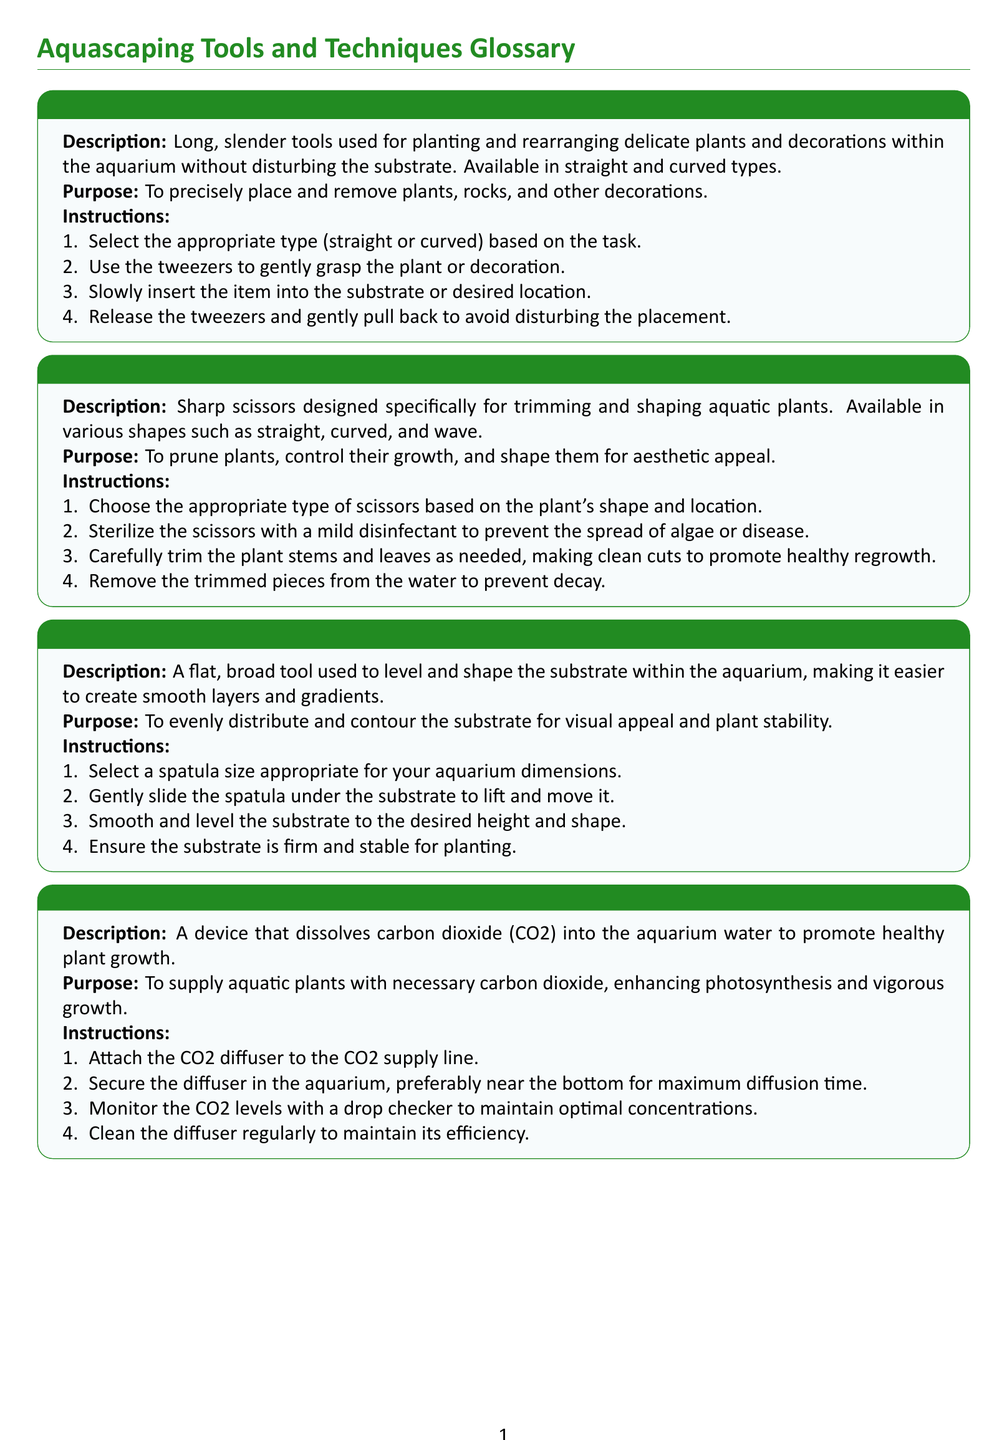What is the purpose of aquarium tweezers? The purpose of aquarium tweezers is to precisely place and remove plants, rocks, and other decorations.
Answer: To precisely place and remove plants, rocks, and other decorations What should you do before using aquarium scissors? Before using aquarium scissors, you should sterilize them with a mild disinfectant to prevent the spread of algae or disease.
Answer: Sterilize the scissors What is aquarium rockwool used for? Aquarium rockwool is used to provide initial support for plant roots and ensure they establish properly in the substrate.
Answer: To provide initial support for plant roots What type of tool is an aquarium substrate spatula? An aquarium substrate spatula is a flat, broad tool used to level and shape the substrate.
Answer: A flat, broad tool How many types of aquarium scissors are available? There are various shapes of aquarium scissors, such as straight, curved, and wave.
Answer: Various shapes What should be monitored after installing a CO2 diffuser? After installing a CO2 diffuser, you should monitor the CO2 levels with a drop checker.
Answer: CO2 levels What do you apply to secure plants with aquarium safe adhesive gel? You apply a small amount of adhesive gel to the base of the plant or decoration.
Answer: A small amount of adhesive gel Which tool is used to promote healthy plant growth by providing CO2? A CO2 diffuser is used to promote healthy plant growth by providing CO2.
Answer: CO2 diffuser What do you do after trimming plant roots for rockwool? After trimming plant roots for rockwool, you insert the roots into the rockwool and gently press them in place.
Answer: Insert the roots into the rockwool 